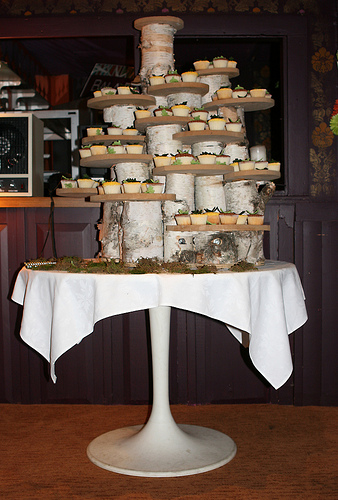<image>
Is there a cake on the floor? No. The cake is not positioned on the floor. They may be near each other, but the cake is not supported by or resting on top of the floor. 